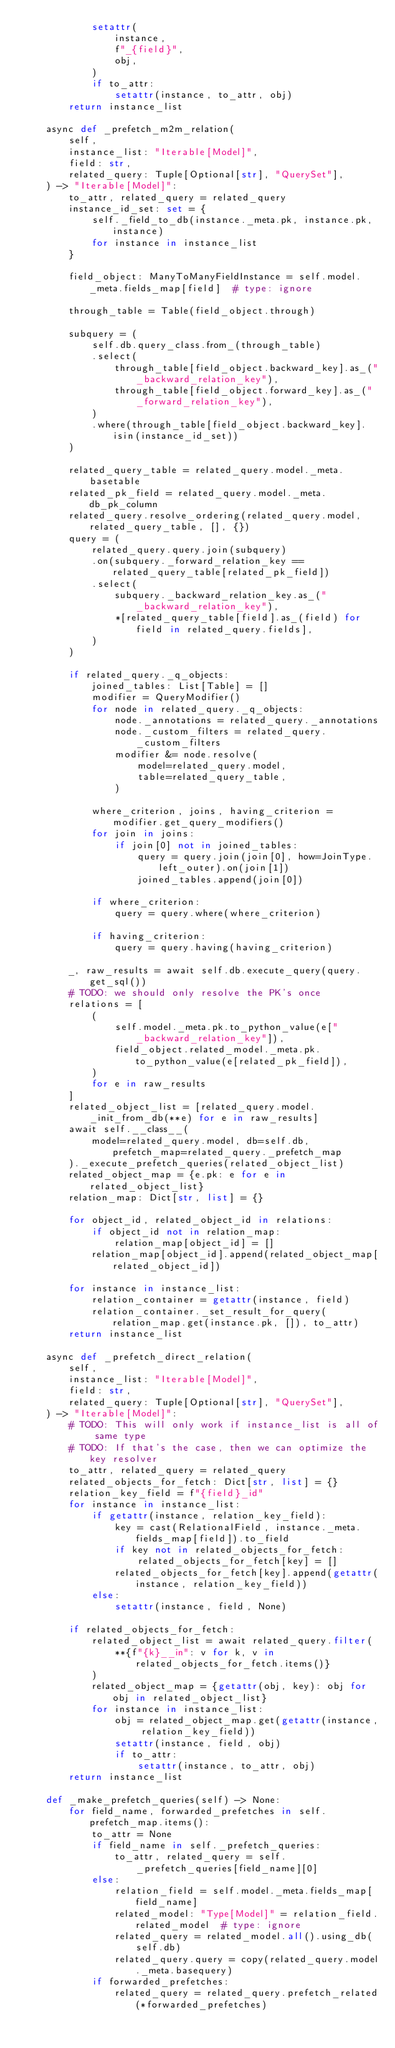Convert code to text. <code><loc_0><loc_0><loc_500><loc_500><_Python_>            setattr(
                instance,
                f"_{field}",
                obj,
            )
            if to_attr:
                setattr(instance, to_attr, obj)
        return instance_list

    async def _prefetch_m2m_relation(
        self,
        instance_list: "Iterable[Model]",
        field: str,
        related_query: Tuple[Optional[str], "QuerySet"],
    ) -> "Iterable[Model]":
        to_attr, related_query = related_query
        instance_id_set: set = {
            self._field_to_db(instance._meta.pk, instance.pk, instance)
            for instance in instance_list
        }

        field_object: ManyToManyFieldInstance = self.model._meta.fields_map[field]  # type: ignore

        through_table = Table(field_object.through)

        subquery = (
            self.db.query_class.from_(through_table)
            .select(
                through_table[field_object.backward_key].as_("_backward_relation_key"),
                through_table[field_object.forward_key].as_("_forward_relation_key"),
            )
            .where(through_table[field_object.backward_key].isin(instance_id_set))
        )

        related_query_table = related_query.model._meta.basetable
        related_pk_field = related_query.model._meta.db_pk_column
        related_query.resolve_ordering(related_query.model, related_query_table, [], {})
        query = (
            related_query.query.join(subquery)
            .on(subquery._forward_relation_key == related_query_table[related_pk_field])
            .select(
                subquery._backward_relation_key.as_("_backward_relation_key"),
                *[related_query_table[field].as_(field) for field in related_query.fields],
            )
        )

        if related_query._q_objects:
            joined_tables: List[Table] = []
            modifier = QueryModifier()
            for node in related_query._q_objects:
                node._annotations = related_query._annotations
                node._custom_filters = related_query._custom_filters
                modifier &= node.resolve(
                    model=related_query.model,
                    table=related_query_table,
                )

            where_criterion, joins, having_criterion = modifier.get_query_modifiers()
            for join in joins:
                if join[0] not in joined_tables:
                    query = query.join(join[0], how=JoinType.left_outer).on(join[1])
                    joined_tables.append(join[0])

            if where_criterion:
                query = query.where(where_criterion)

            if having_criterion:
                query = query.having(having_criterion)

        _, raw_results = await self.db.execute_query(query.get_sql())
        # TODO: we should only resolve the PK's once
        relations = [
            (
                self.model._meta.pk.to_python_value(e["_backward_relation_key"]),
                field_object.related_model._meta.pk.to_python_value(e[related_pk_field]),
            )
            for e in raw_results
        ]
        related_object_list = [related_query.model._init_from_db(**e) for e in raw_results]
        await self.__class__(
            model=related_query.model, db=self.db, prefetch_map=related_query._prefetch_map
        )._execute_prefetch_queries(related_object_list)
        related_object_map = {e.pk: e for e in related_object_list}
        relation_map: Dict[str, list] = {}

        for object_id, related_object_id in relations:
            if object_id not in relation_map:
                relation_map[object_id] = []
            relation_map[object_id].append(related_object_map[related_object_id])

        for instance in instance_list:
            relation_container = getattr(instance, field)
            relation_container._set_result_for_query(relation_map.get(instance.pk, []), to_attr)
        return instance_list

    async def _prefetch_direct_relation(
        self,
        instance_list: "Iterable[Model]",
        field: str,
        related_query: Tuple[Optional[str], "QuerySet"],
    ) -> "Iterable[Model]":
        # TODO: This will only work if instance_list is all of same type
        # TODO: If that's the case, then we can optimize the key resolver
        to_attr, related_query = related_query
        related_objects_for_fetch: Dict[str, list] = {}
        relation_key_field = f"{field}_id"
        for instance in instance_list:
            if getattr(instance, relation_key_field):
                key = cast(RelationalField, instance._meta.fields_map[field]).to_field
                if key not in related_objects_for_fetch:
                    related_objects_for_fetch[key] = []
                related_objects_for_fetch[key].append(getattr(instance, relation_key_field))
            else:
                setattr(instance, field, None)

        if related_objects_for_fetch:
            related_object_list = await related_query.filter(
                **{f"{k}__in": v for k, v in related_objects_for_fetch.items()}
            )
            related_object_map = {getattr(obj, key): obj for obj in related_object_list}
            for instance in instance_list:
                obj = related_object_map.get(getattr(instance, relation_key_field))
                setattr(instance, field, obj)
                if to_attr:
                    setattr(instance, to_attr, obj)
        return instance_list

    def _make_prefetch_queries(self) -> None:
        for field_name, forwarded_prefetches in self.prefetch_map.items():
            to_attr = None
            if field_name in self._prefetch_queries:
                to_attr, related_query = self._prefetch_queries[field_name][0]
            else:
                relation_field = self.model._meta.fields_map[field_name]
                related_model: "Type[Model]" = relation_field.related_model  # type: ignore
                related_query = related_model.all().using_db(self.db)
                related_query.query = copy(related_query.model._meta.basequery)
            if forwarded_prefetches:
                related_query = related_query.prefetch_related(*forwarded_prefetches)</code> 